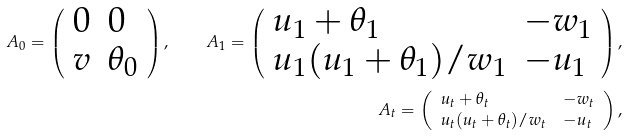Convert formula to latex. <formula><loc_0><loc_0><loc_500><loc_500>A _ { 0 } = \left ( \begin{array} { l l } 0 & 0 \\ v & \theta _ { 0 } \end{array} \right ) , \quad A _ { 1 } = \left ( \begin{array} { l l } u _ { 1 } + \theta _ { 1 } & - w _ { 1 } \\ u _ { 1 } ( u _ { 1 } + \theta _ { 1 } ) / w _ { 1 } & - u _ { 1 } \end{array} \right ) , \\ A _ { t } = \left ( \begin{array} { l l } u _ { t } + \theta _ { t } & - w _ { t } \\ u _ { t } ( u _ { t } + \theta _ { t } ) / w _ { t } & - u _ { t } \end{array} \right ) ,</formula> 